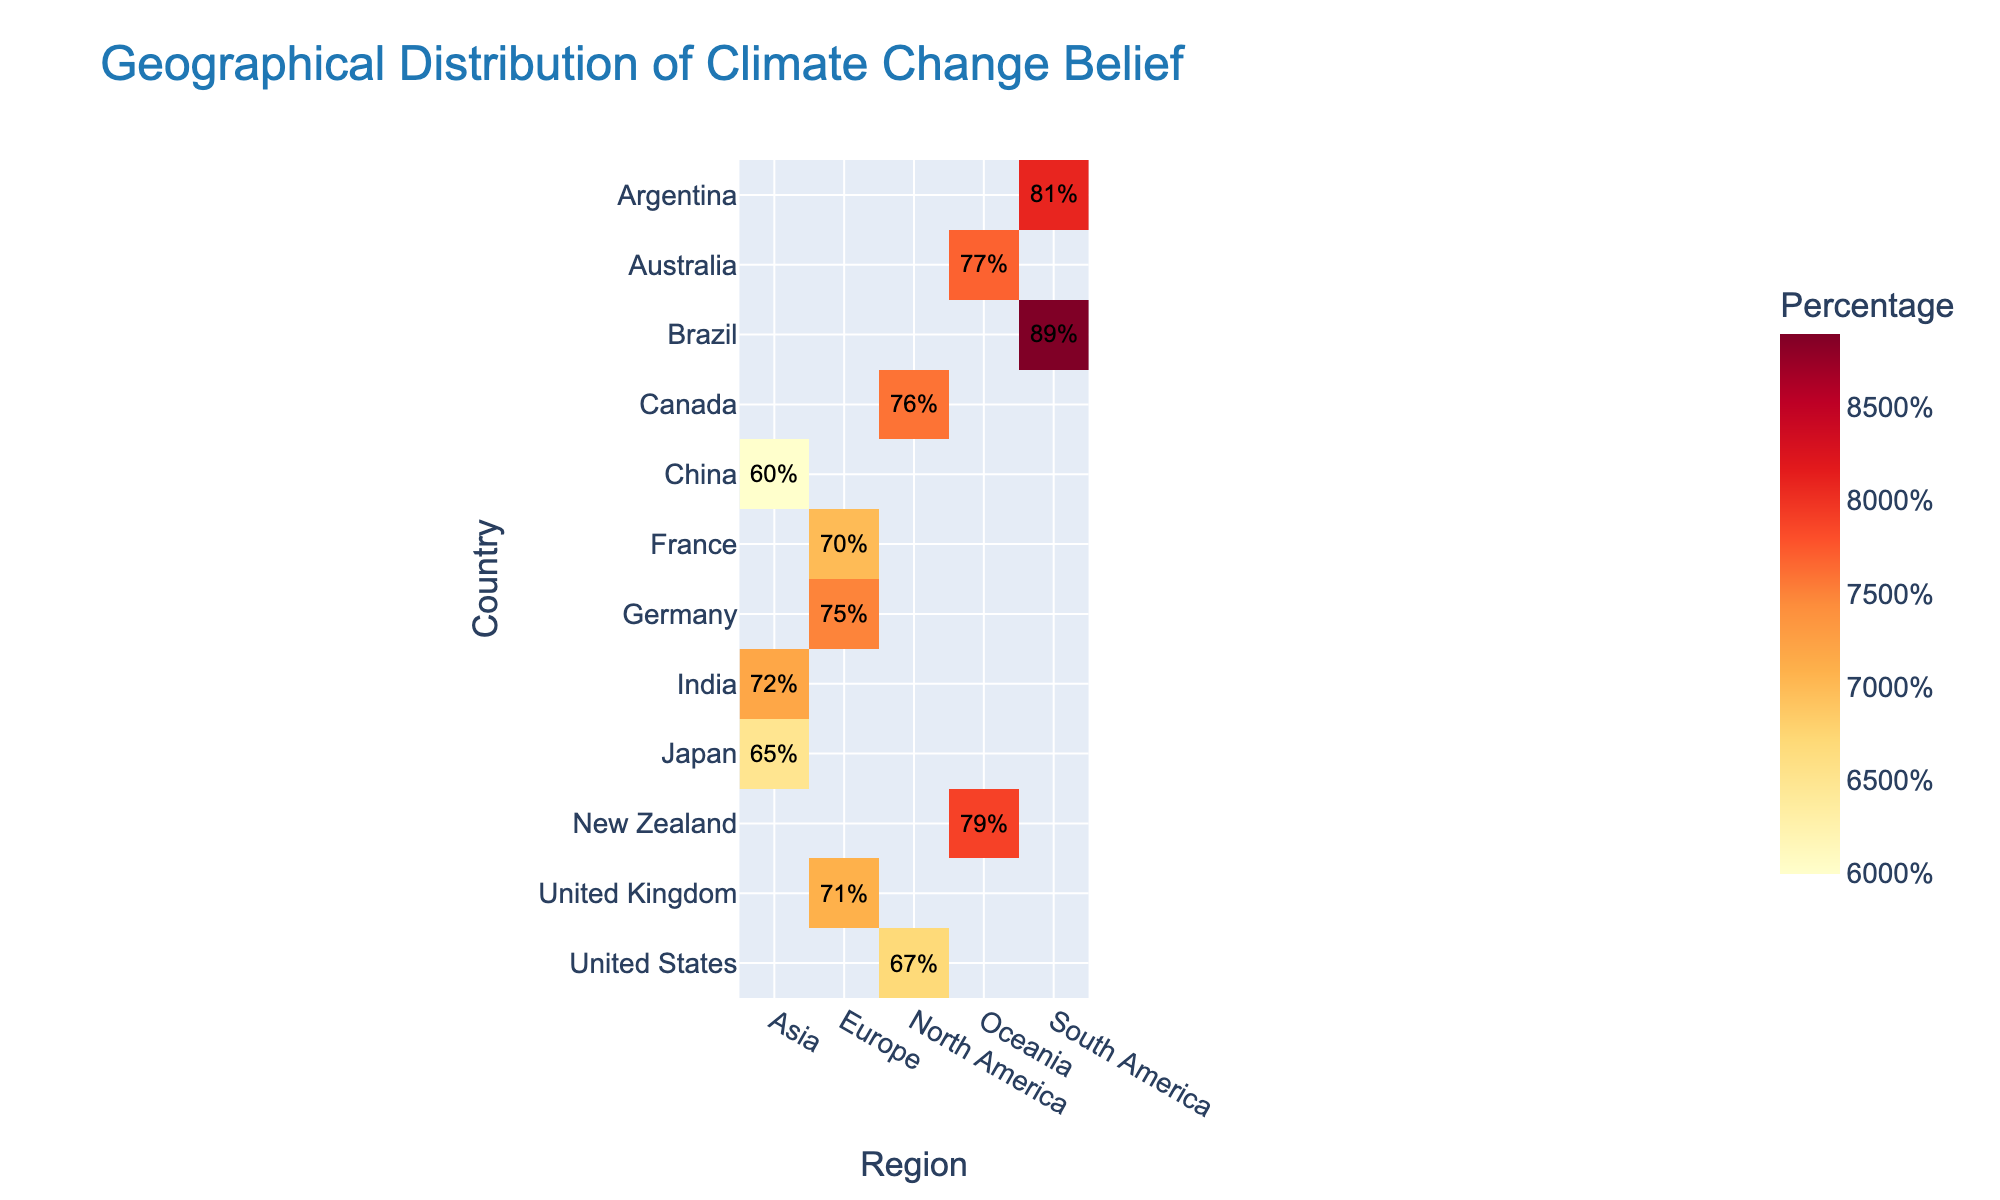what is the title of the heatmap? The title of the heatmap is typically located at the top of the figure, often written in larger font to be easily noticed.
Answer: Geographical Distribution of Climate Change Belief which country has the highest belief in climate change? Look at the color intensity and the annotations on the heatmap. The country with the highest percentage will have the darkest color and the highest number.
Answer: Brazil what percentage of people in Germany believe in climate change? Locate Germany on the y-axis and follow the row to the value in the 'Europe' column. The text annotation should indicate the exact percentage.
Answer: 75% compare the belief in climate change between the United States and Canada. Look at the values for the United States and Canada. The numbers show that 67% believe in the United States and 76% in Canada. Therefore, more people in Canada believe in climate change than in the United States.
Answer: Canada (76%) > United States (67%) which region has the most countries listed in the heatmap? Count the number of unique countries within each region's column. Compare these counts to determine which region has the highest number of countries represented.
Answer: Europe what is the average belief in climate change in Asia? Find the values for all the Asian countries (China, India, Japan). Add these values together and divide by the number of Asian countries to find the average: (60 + 72 + 65) / 3.
Answer: 65.67% identify the countries with belief percentages greater than 75%. Locate all the countries where the percent belief in climate change is above 75% by reviewing the annotations and color intensity on the heatmap.
Answer: Canada, Germany, Australia, New Zealand, Brazil what is the range of belief in climate change percentages among the countries in Oceania? Identify the lowest and highest percentages in the Oceania column and subtract the smallest percentage from the largest percentage. For Oceania, the countries are Australia (77%) and New Zealand (79%). The range is 79 - 77.
Answer: 2% is there any country in Asia where the belief in climate change is below 65%? Look at the values for the Asian countries in the heatmap and identify which, if any, have a percentage less than 65%.
Answer: China 